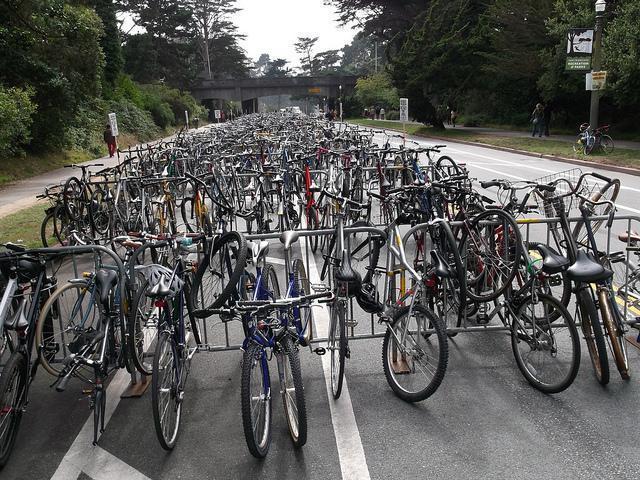What type of transportation is shown?
Choose the right answer and clarify with the format: 'Answer: answer
Rationale: rationale.'
Options: Air, rail, road, water. Answer: road.
Rationale: The bikes are on a street. 